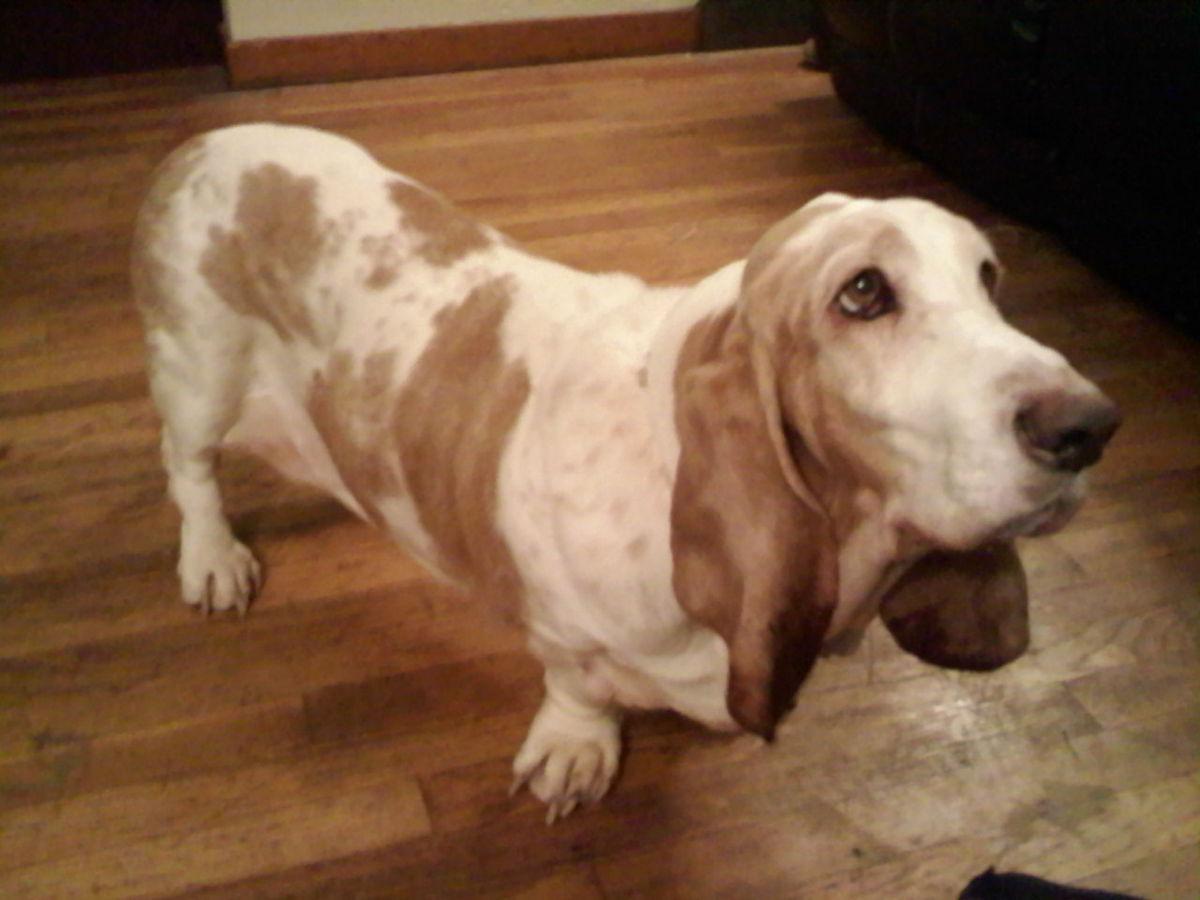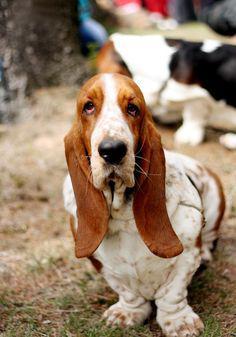The first image is the image on the left, the second image is the image on the right. Assess this claim about the two images: "One image shows a basset hound standing on all fours in profile, and the other image shows a basset hound viewed head on.". Correct or not? Answer yes or no. Yes. 